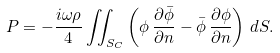<formula> <loc_0><loc_0><loc_500><loc_500>P = - \frac { i \omega \rho } { 4 } \iint _ { S _ { C } } \left ( \phi \, \frac { \partial \bar { \phi } } { \partial n } - \bar { \phi } \, \frac { \partial \phi } { \partial n } \right ) \, d S .</formula> 